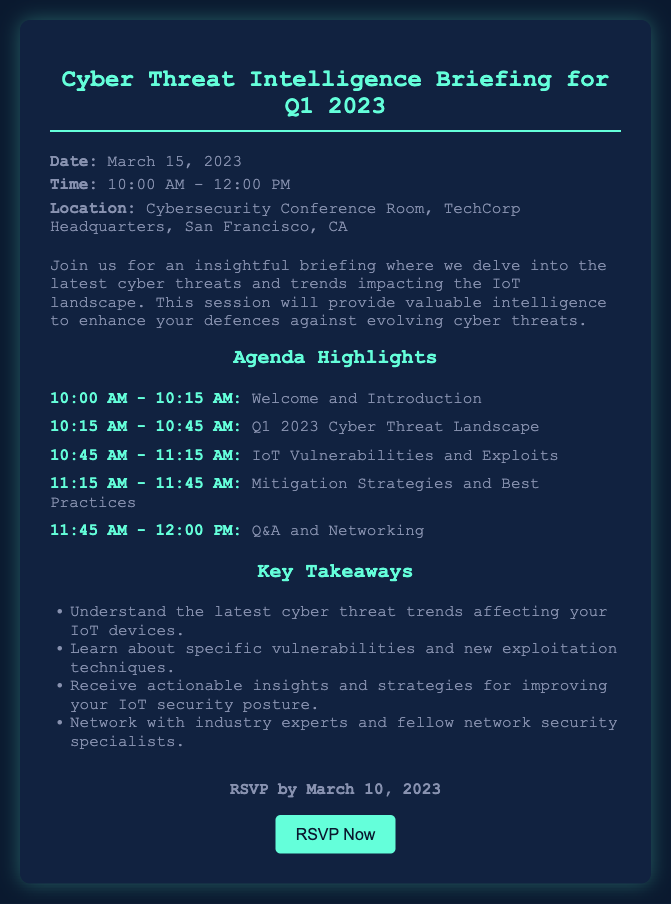What is the date of the briefing? The date of the briefing is specifically mentioned in the document.
Answer: March 15, 2023 What time does the briefing start? The start time is provided in the document under the event details.
Answer: 10:00 AM Where is the location of the event? The location is clearly stated in the document.
Answer: Cybersecurity Conference Room, TechCorp Headquarters, San Francisco, CA What is one of the key takeaways from the briefing? The document lists several key takeaways relevant to the event.
Answer: Understand the latest cyber threat trends affecting your IoT devices What is the end time of the briefing? The end time is also mentioned in the event's schedule.
Answer: 12:00 PM How long is the "Q&A and Networking" session? The duration of the session is derived from the scheduled agenda in the document.
Answer: 15 minutes What is the RSVP deadline? The deadline for RSVP is noted in the document.
Answer: March 10, 2023 What is the agenda item immediately following the introduction? The agenda item sequence is listed in the document.
Answer: Q1 2023 Cyber Threat Landscape Who should be contacted to RSVP? The contact information for RSVPing is provided in the document.
Answer: security-events@techcorp.com 